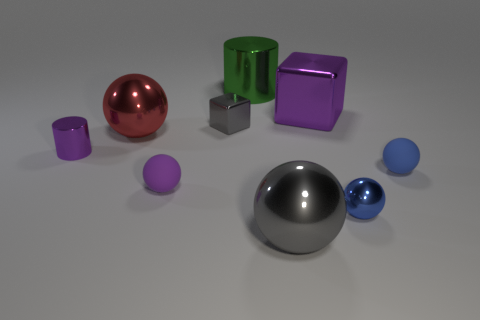What size is the other cube that is the same material as the gray block?
Give a very brief answer. Large. The small cylinder is what color?
Your answer should be very brief. Purple. How big is the shiny cube on the left side of the green object that is to the left of the gray shiny thing that is in front of the small purple metal object?
Your response must be concise. Small. How many other things are the same shape as the red shiny thing?
Provide a short and direct response. 4. What is the color of the sphere that is on the left side of the green metal object and in front of the purple metal cylinder?
Provide a short and direct response. Purple. Do the tiny rubber object to the left of the blue matte thing and the small cylinder have the same color?
Keep it short and to the point. Yes. How many cylinders are small gray metallic things or large red matte things?
Your response must be concise. 0. There is a purple metallic thing behind the small gray block; what shape is it?
Your response must be concise. Cube. The cylinder right of the sphere behind the object to the left of the red metal thing is what color?
Your response must be concise. Green. Does the big cube have the same material as the large gray object?
Ensure brevity in your answer.  Yes. 